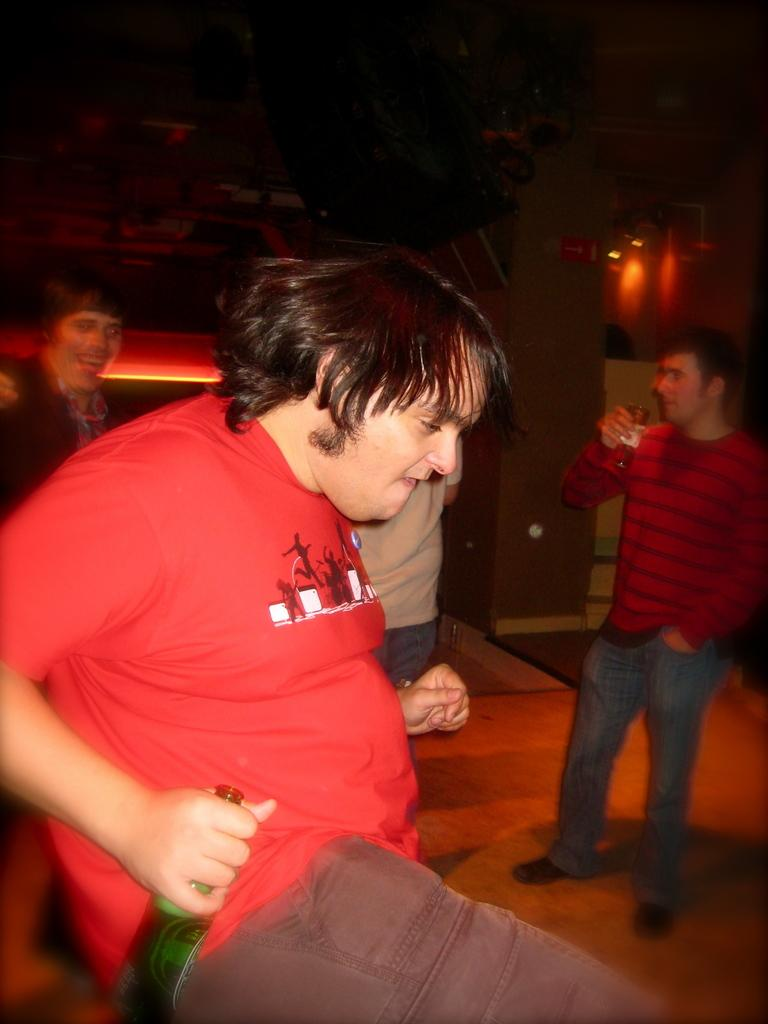Who is the main subject in the image? There is a man in the center of the image. What is the man holding in his hand? The man is holding a bottle in his hand. Can you describe the background of the image? There are other people and lights in the background of the image. What type of butter is being used for division in the image? There is no butter or division present in the image. 